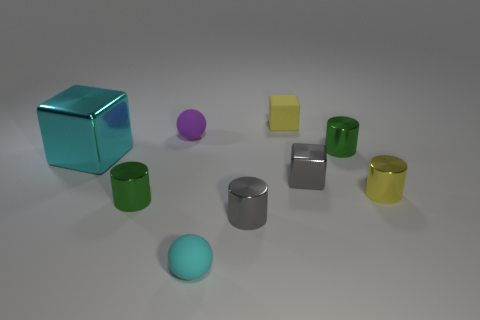Subtract all small blocks. How many blocks are left? 1 Subtract all blue spheres. How many green cylinders are left? 2 Subtract 2 cylinders. How many cylinders are left? 2 Subtract all gray cylinders. How many cylinders are left? 3 Subtract all cylinders. How many objects are left? 5 Subtract all yellow cylinders. Subtract all cyan spheres. How many cylinders are left? 3 Add 3 big metallic blocks. How many big metallic blocks exist? 4 Subtract 0 cyan cylinders. How many objects are left? 9 Subtract all small gray metallic objects. Subtract all yellow matte balls. How many objects are left? 7 Add 3 small yellow metal objects. How many small yellow metal objects are left? 4 